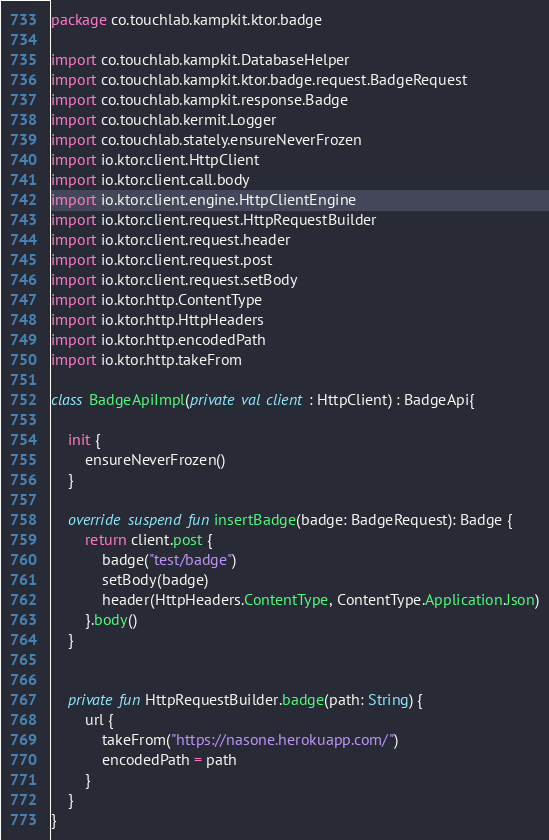Convert code to text. <code><loc_0><loc_0><loc_500><loc_500><_Kotlin_>package co.touchlab.kampkit.ktor.badge

import co.touchlab.kampkit.DatabaseHelper
import co.touchlab.kampkit.ktor.badge.request.BadgeRequest
import co.touchlab.kampkit.response.Badge
import co.touchlab.kermit.Logger
import co.touchlab.stately.ensureNeverFrozen
import io.ktor.client.HttpClient
import io.ktor.client.call.body
import io.ktor.client.engine.HttpClientEngine
import io.ktor.client.request.HttpRequestBuilder
import io.ktor.client.request.header
import io.ktor.client.request.post
import io.ktor.client.request.setBody
import io.ktor.http.ContentType
import io.ktor.http.HttpHeaders
import io.ktor.http.encodedPath
import io.ktor.http.takeFrom

class BadgeApiImpl(private val client : HttpClient) : BadgeApi{

    init {
        ensureNeverFrozen()
    }

    override suspend fun insertBadge(badge: BadgeRequest): Badge {
        return client.post {
            badge("test/badge")
            setBody(badge)
            header(HttpHeaders.ContentType, ContentType.Application.Json)
        }.body()
    }


    private fun HttpRequestBuilder.badge(path: String) {
        url {
            takeFrom("https://nasone.herokuapp.com/")
            encodedPath = path
        }
    }
}</code> 